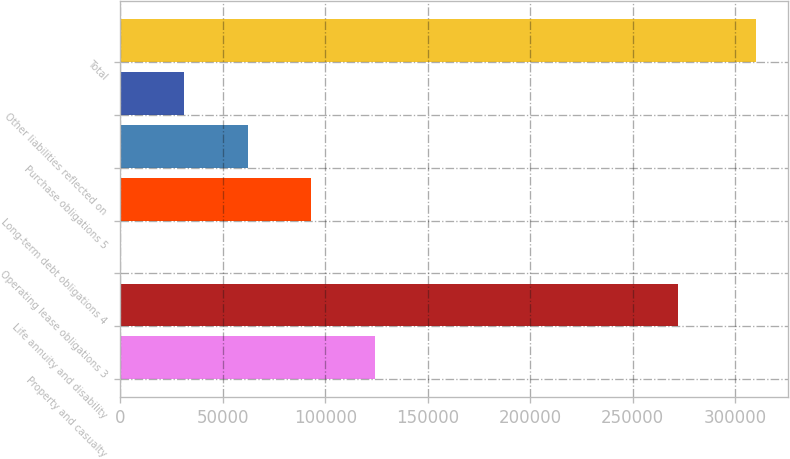Convert chart. <chart><loc_0><loc_0><loc_500><loc_500><bar_chart><fcel>Property and casualty<fcel>Life annuity and disability<fcel>Operating lease obligations 3<fcel>Long-term debt obligations 4<fcel>Purchase obligations 5<fcel>Other liabilities reflected on<fcel>Total<nl><fcel>124109<fcel>272187<fcel>154<fcel>93120.1<fcel>62131.4<fcel>31142.7<fcel>310041<nl></chart> 